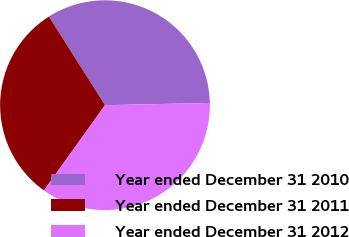<chart> <loc_0><loc_0><loc_500><loc_500><pie_chart><fcel>Year ended December 31 2010<fcel>Year ended December 31 2011<fcel>Year ended December 31 2012<nl><fcel>33.64%<fcel>31.13%<fcel>35.23%<nl></chart> 